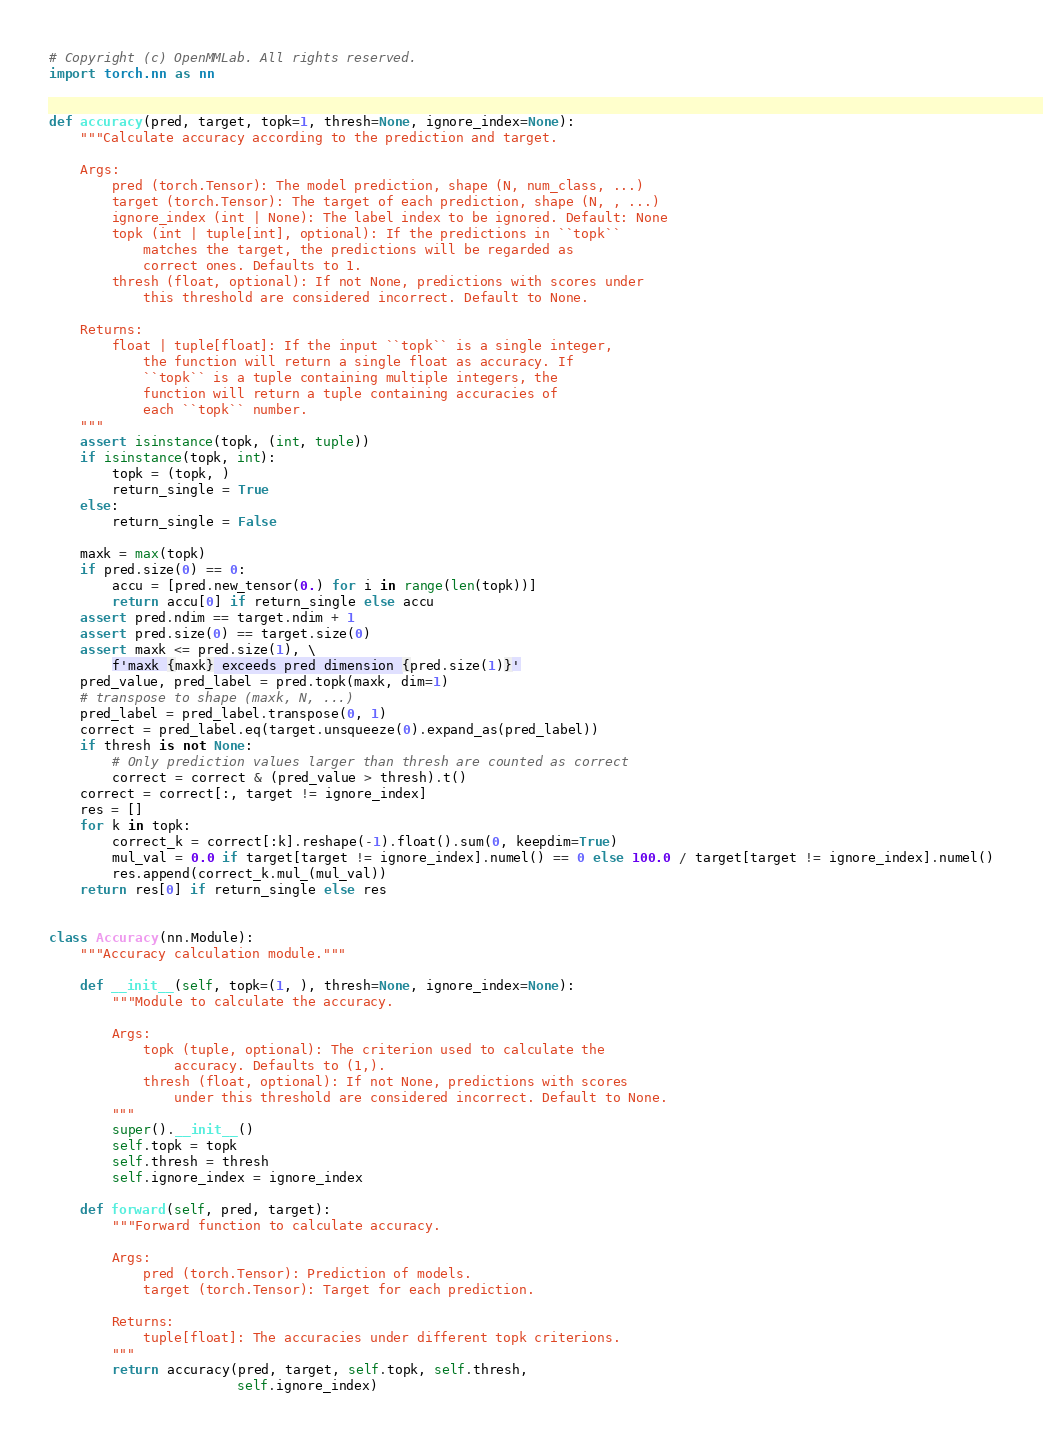Convert code to text. <code><loc_0><loc_0><loc_500><loc_500><_Python_># Copyright (c) OpenMMLab. All rights reserved.
import torch.nn as nn


def accuracy(pred, target, topk=1, thresh=None, ignore_index=None):
    """Calculate accuracy according to the prediction and target.

    Args:
        pred (torch.Tensor): The model prediction, shape (N, num_class, ...)
        target (torch.Tensor): The target of each prediction, shape (N, , ...)
        ignore_index (int | None): The label index to be ignored. Default: None
        topk (int | tuple[int], optional): If the predictions in ``topk``
            matches the target, the predictions will be regarded as
            correct ones. Defaults to 1.
        thresh (float, optional): If not None, predictions with scores under
            this threshold are considered incorrect. Default to None.

    Returns:
        float | tuple[float]: If the input ``topk`` is a single integer,
            the function will return a single float as accuracy. If
            ``topk`` is a tuple containing multiple integers, the
            function will return a tuple containing accuracies of
            each ``topk`` number.
    """
    assert isinstance(topk, (int, tuple))
    if isinstance(topk, int):
        topk = (topk, )
        return_single = True
    else:
        return_single = False

    maxk = max(topk)
    if pred.size(0) == 0:
        accu = [pred.new_tensor(0.) for i in range(len(topk))]
        return accu[0] if return_single else accu
    assert pred.ndim == target.ndim + 1
    assert pred.size(0) == target.size(0)
    assert maxk <= pred.size(1), \
        f'maxk {maxk} exceeds pred dimension {pred.size(1)}'
    pred_value, pred_label = pred.topk(maxk, dim=1)
    # transpose to shape (maxk, N, ...)
    pred_label = pred_label.transpose(0, 1)
    correct = pred_label.eq(target.unsqueeze(0).expand_as(pred_label))
    if thresh is not None:
        # Only prediction values larger than thresh are counted as correct
        correct = correct & (pred_value > thresh).t()
    correct = correct[:, target != ignore_index]
    res = []
    for k in topk:
        correct_k = correct[:k].reshape(-1).float().sum(0, keepdim=True)
        mul_val = 0.0 if target[target != ignore_index].numel() == 0 else 100.0 / target[target != ignore_index].numel()
        res.append(correct_k.mul_(mul_val))
    return res[0] if return_single else res


class Accuracy(nn.Module):
    """Accuracy calculation module."""

    def __init__(self, topk=(1, ), thresh=None, ignore_index=None):
        """Module to calculate the accuracy.

        Args:
            topk (tuple, optional): The criterion used to calculate the
                accuracy. Defaults to (1,).
            thresh (float, optional): If not None, predictions with scores
                under this threshold are considered incorrect. Default to None.
        """
        super().__init__()
        self.topk = topk
        self.thresh = thresh
        self.ignore_index = ignore_index

    def forward(self, pred, target):
        """Forward function to calculate accuracy.

        Args:
            pred (torch.Tensor): Prediction of models.
            target (torch.Tensor): Target for each prediction.

        Returns:
            tuple[float]: The accuracies under different topk criterions.
        """
        return accuracy(pred, target, self.topk, self.thresh,
                        self.ignore_index)
</code> 